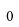Convert formula to latex. <formula><loc_0><loc_0><loc_500><loc_500>0</formula> 